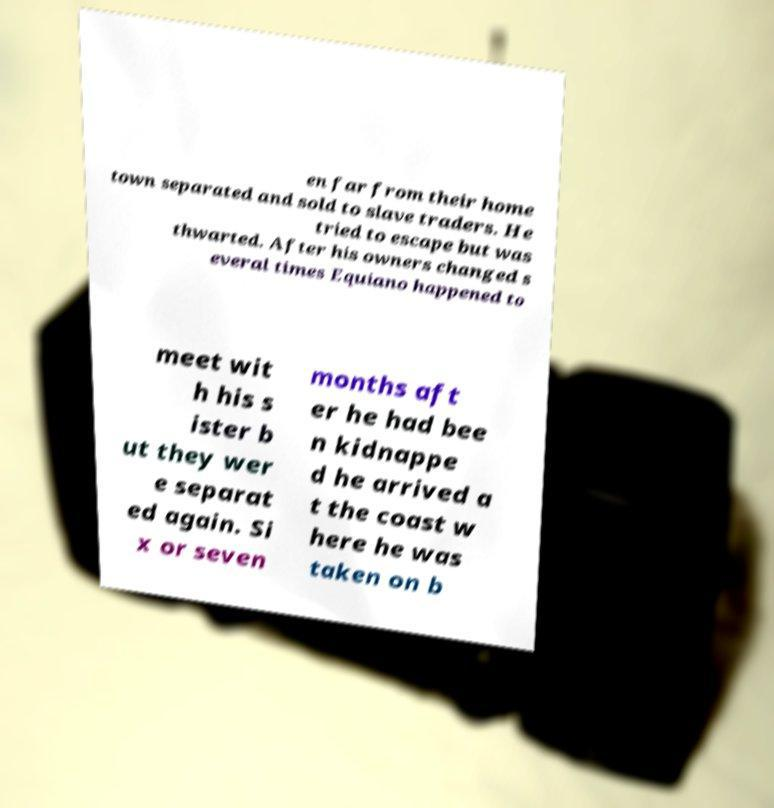Could you assist in decoding the text presented in this image and type it out clearly? en far from their home town separated and sold to slave traders. He tried to escape but was thwarted. After his owners changed s everal times Equiano happened to meet wit h his s ister b ut they wer e separat ed again. Si x or seven months aft er he had bee n kidnappe d he arrived a t the coast w here he was taken on b 